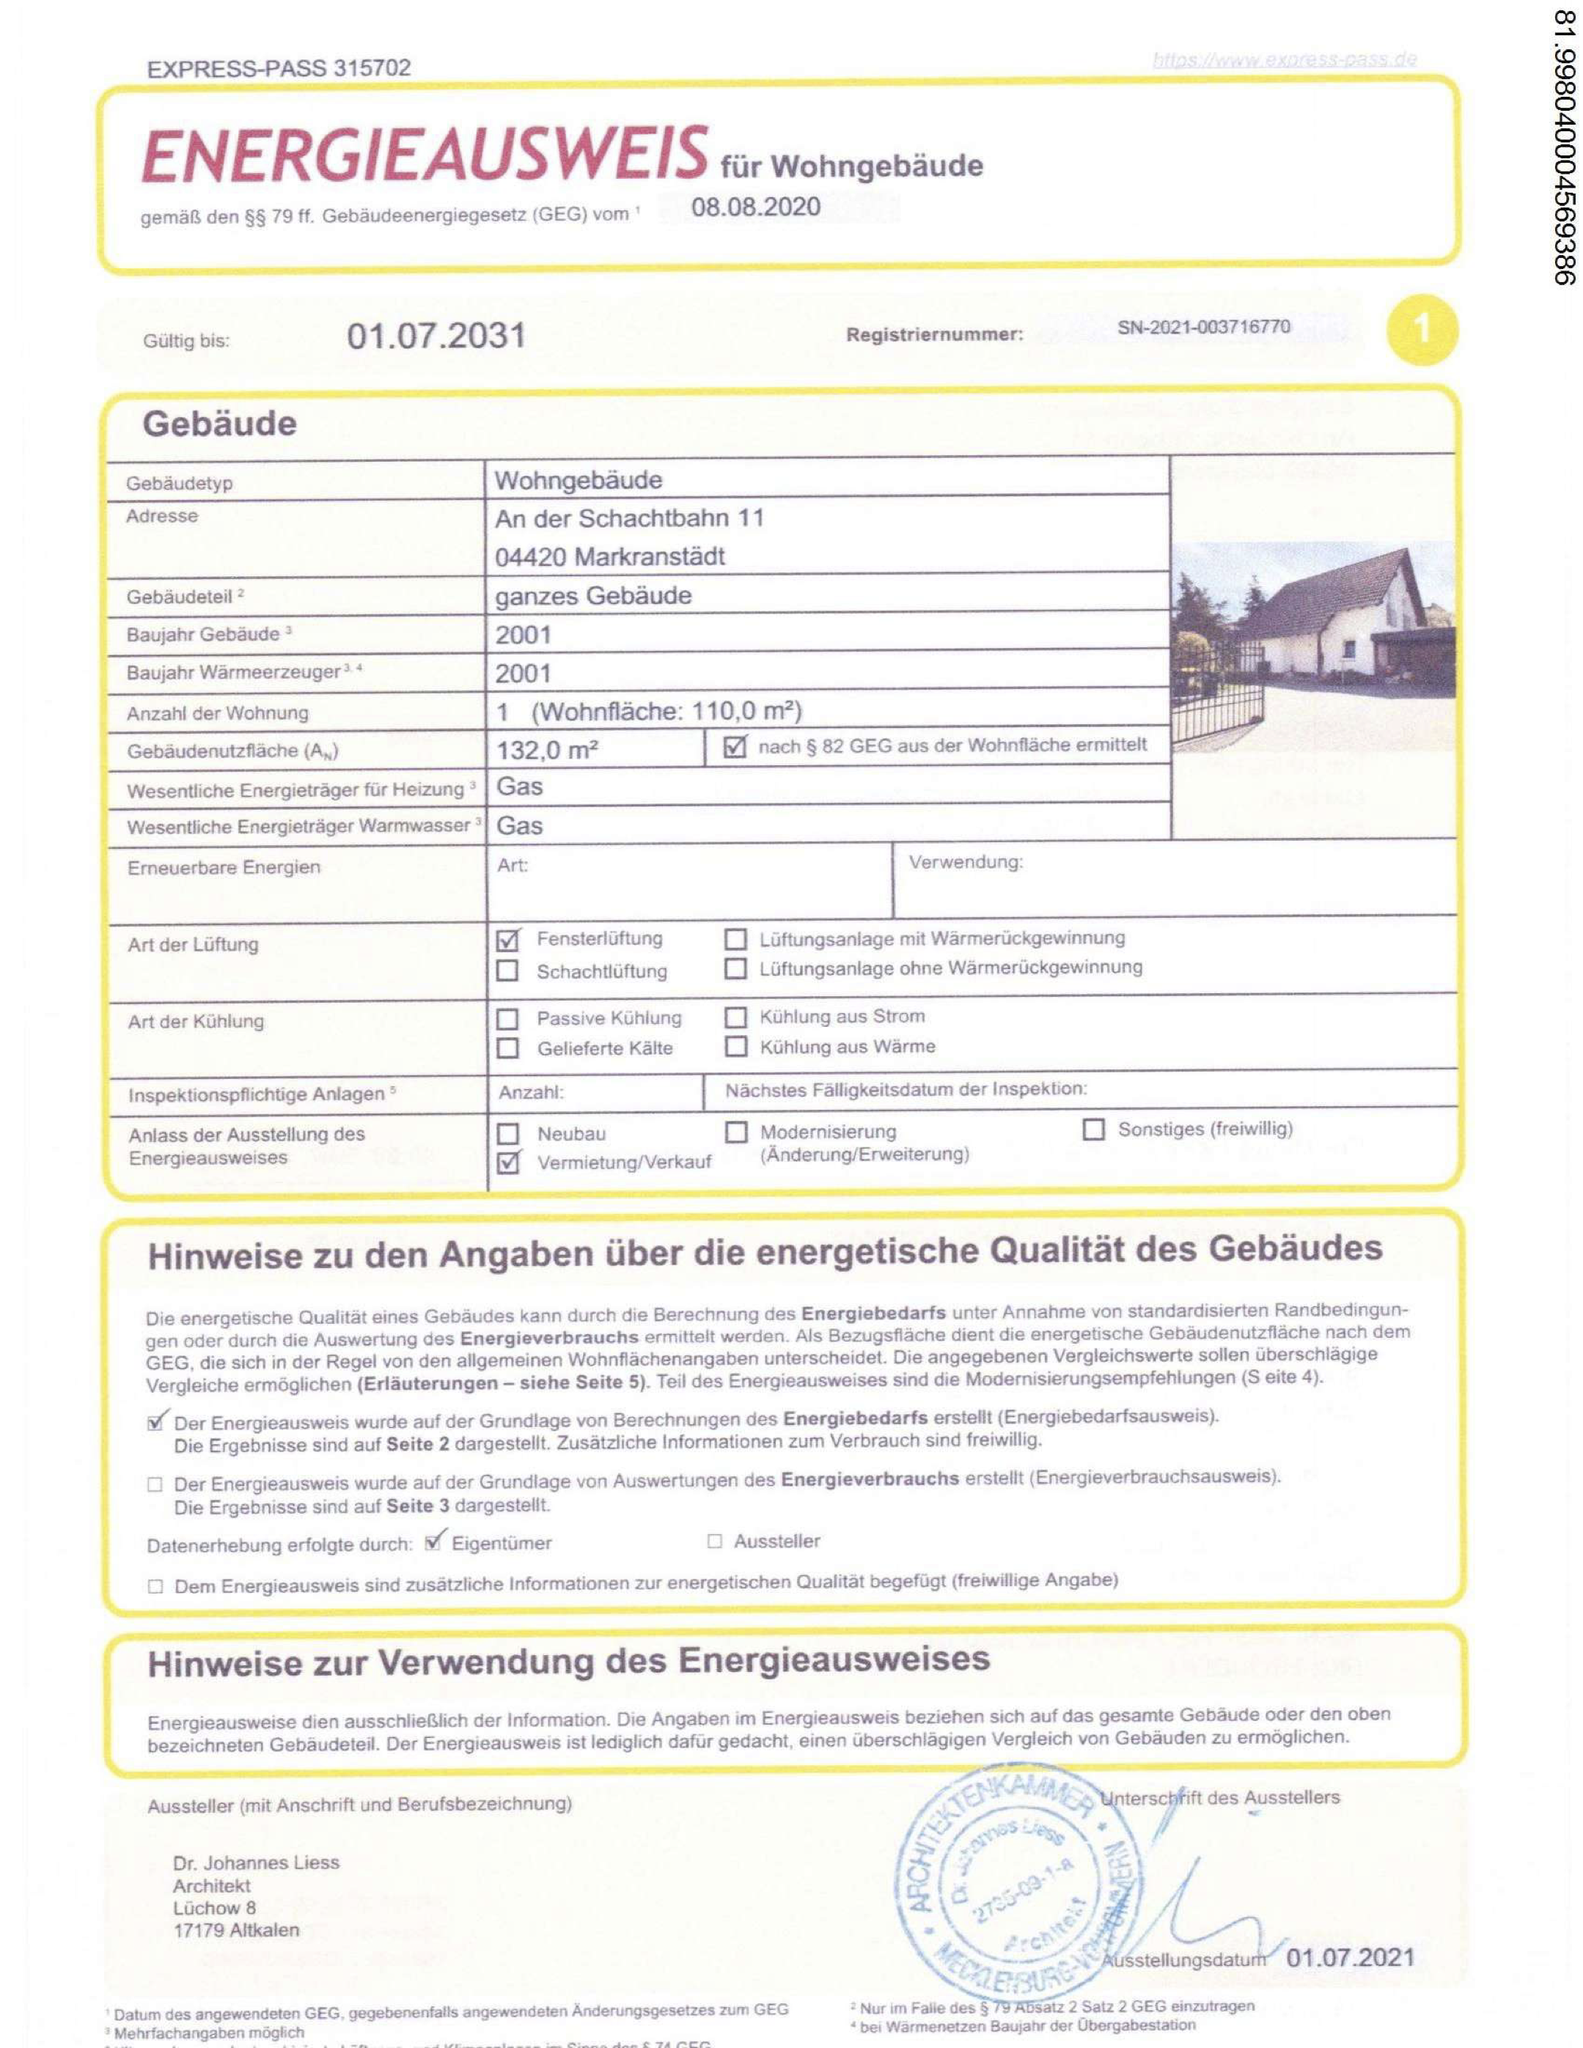Was ist der wesentliche Energieträger für Warmwasser? Der wesentliche Energieträger für Warmwasser in dem dargestellten Energieausweis ist "Gas". Dies ist im Abschnitt "Wesentliche Energieträger für Heizung" und "Wesentliche Energieträger für Warmwasser" angegeben, wo jeweils "Gas" als Energiequelle aufgeführt ist. 